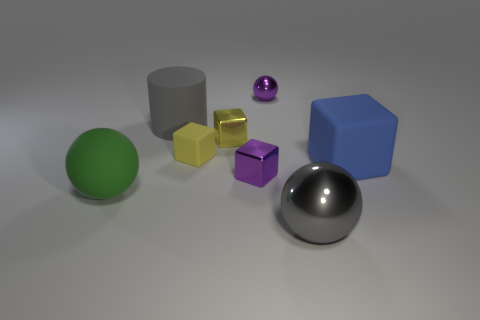Subtract 1 cubes. How many cubes are left? 3 Add 1 large blue matte things. How many objects exist? 9 Subtract all cylinders. How many objects are left? 7 Add 7 large matte cylinders. How many large matte cylinders are left? 8 Add 2 large matte balls. How many large matte balls exist? 3 Subtract 0 green cubes. How many objects are left? 8 Subtract all big gray matte things. Subtract all big blue objects. How many objects are left? 6 